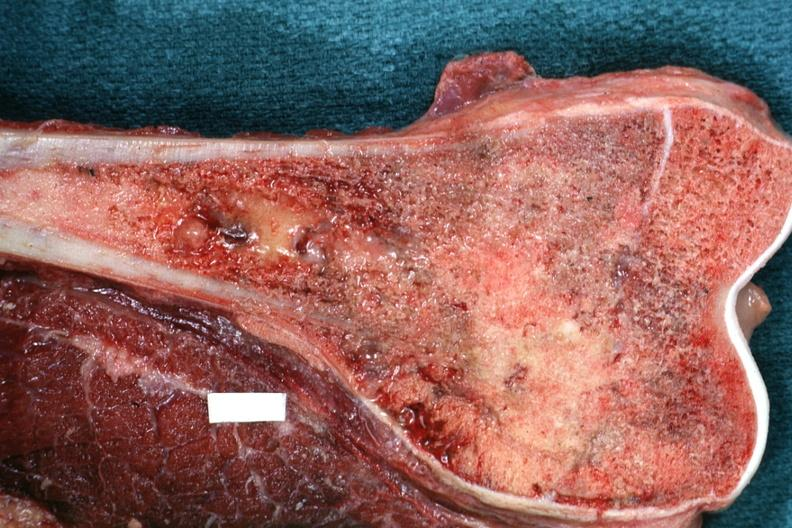s sectioned femur lesion distal end excellent example?
Answer the question using a single word or phrase. Yes 